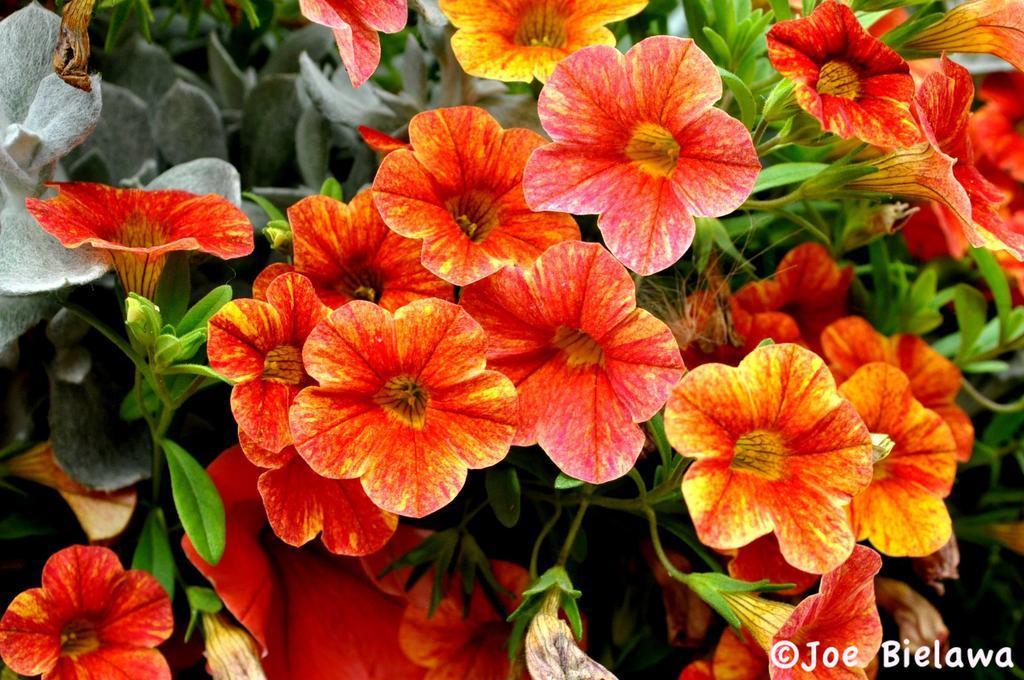Please provide a concise description of this image. In this image I can see many leaves and flowers. The flowers are in yellow and red colors. In the bottom right-hand corner there is some text. 